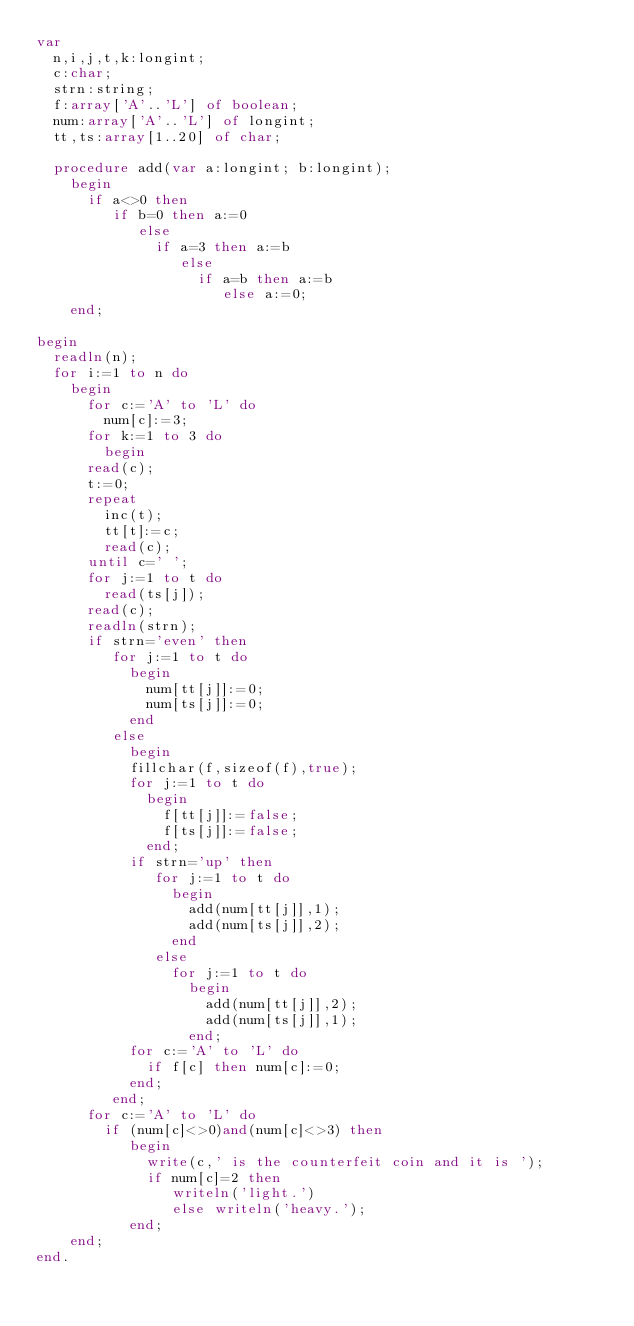Convert code to text. <code><loc_0><loc_0><loc_500><loc_500><_Pascal_>var
  n,i,j,t,k:longint;
  c:char;
  strn:string;
  f:array['A'..'L'] of boolean;
  num:array['A'..'L'] of longint;
  tt,ts:array[1..20] of char;

  procedure add(var a:longint; b:longint);
    begin
      if a<>0 then
         if b=0 then a:=0
            else
              if a=3 then a:=b
                 else
                   if a=b then a:=b
                      else a:=0;
    end;

begin
  readln(n);
  for i:=1 to n do
    begin
      for c:='A' to 'L' do
        num[c]:=3;
      for k:=1 to 3 do
        begin
      read(c);
      t:=0;
      repeat
        inc(t);
        tt[t]:=c;
        read(c);
      until c=' ';
      for j:=1 to t do
        read(ts[j]);
      read(c);
      readln(strn);
      if strn='even' then
         for j:=1 to t do
           begin
             num[tt[j]]:=0;
             num[ts[j]]:=0;
           end
         else
           begin
           fillchar(f,sizeof(f),true);
           for j:=1 to t do
             begin
               f[tt[j]]:=false;
               f[ts[j]]:=false;
             end;
           if strn='up' then
              for j:=1 to t do
                begin
                  add(num[tt[j]],1);
                  add(num[ts[j]],2);
                end
              else
                for j:=1 to t do
                  begin
                    add(num[tt[j]],2);
                    add(num[ts[j]],1);
                  end;
           for c:='A' to 'L' do
             if f[c] then num[c]:=0;
           end;
         end;
      for c:='A' to 'L' do
        if (num[c]<>0)and(num[c]<>3) then
           begin
             write(c,' is the counterfeit coin and it is ');
             if num[c]=2 then
                writeln('light.')
                else writeln('heavy.');
           end;
    end;
end.
</code> 